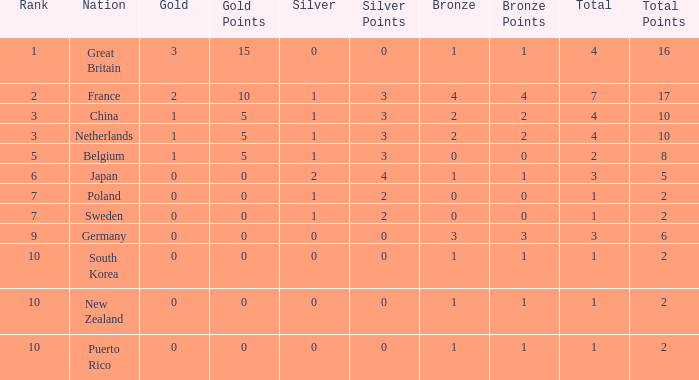What is the smallest number of gold where the total is less than 3 and the silver count is 2? None. Could you help me parse every detail presented in this table? {'header': ['Rank', 'Nation', 'Gold', 'Gold Points', 'Silver', 'Silver Points', 'Bronze', 'Bronze Points', 'Total', 'Total Points'], 'rows': [['1', 'Great Britain', '3', '15', '0', '0', '1', '1', '4', '16'], ['2', 'France', '2', '10', '1', '3', '4', '4', '7', '17'], ['3', 'China', '1', '5', '1', '3', '2', '2', '4', '10'], ['3', 'Netherlands', '1', '5', '1', '3', '2', '2', '4', '10'], ['5', 'Belgium', '1', '5', '1', '3', '0', '0', '2', '8'], ['6', 'Japan', '0', '0', '2', '4', '1', '1', '3', '5'], ['7', 'Poland', '0', '0', '1', '2', '0', '0', '1', '2'], ['7', 'Sweden', '0', '0', '1', '2', '0', '0', '1', '2'], ['9', 'Germany', '0', '0', '0', '0', '3', '3', '3', '6'], ['10', 'South Korea', '0', '0', '0', '0', '1', '1', '1', '2'], ['10', 'New Zealand', '0', '0', '0', '0', '1', '1', '1', '2'], ['10', 'Puerto Rico', '0', '0', '0', '0', '1', '1', '1', '2']]} 